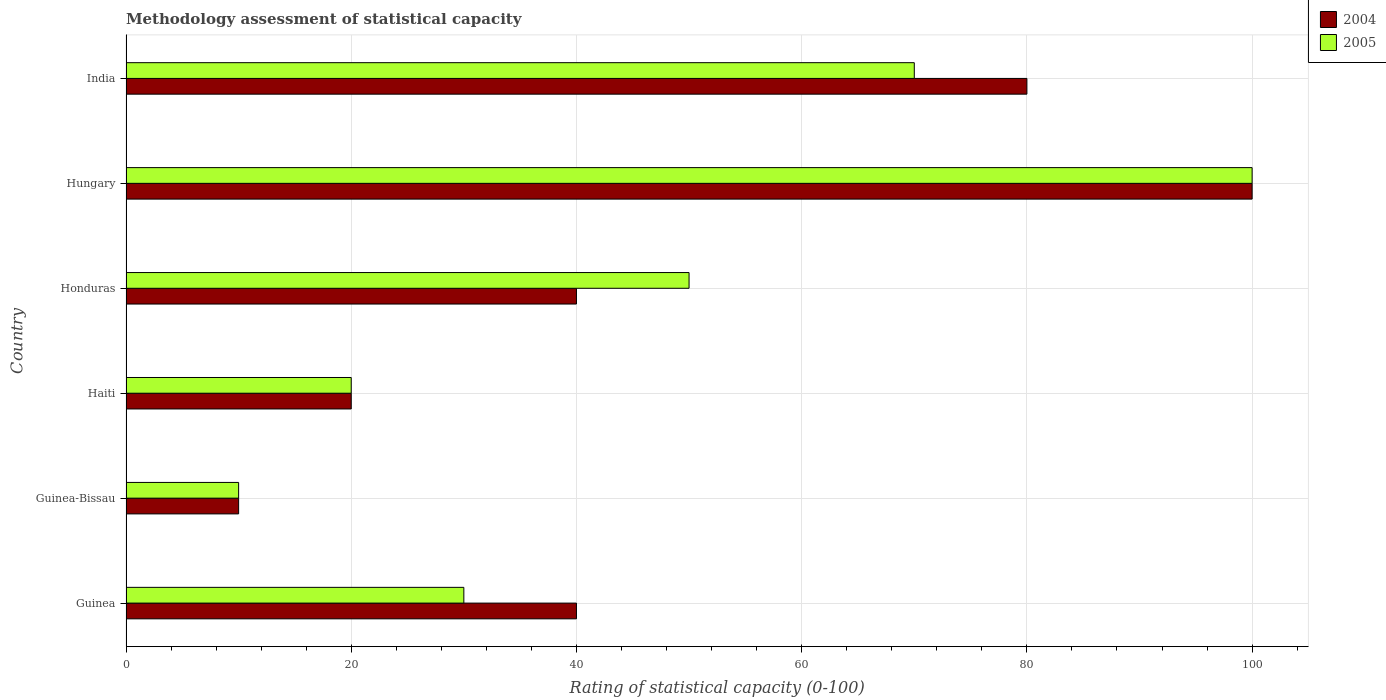How many different coloured bars are there?
Offer a very short reply. 2. How many groups of bars are there?
Provide a succinct answer. 6. What is the label of the 6th group of bars from the top?
Give a very brief answer. Guinea. Across all countries, what is the minimum rating of statistical capacity in 2005?
Ensure brevity in your answer.  10. In which country was the rating of statistical capacity in 2005 maximum?
Your response must be concise. Hungary. In which country was the rating of statistical capacity in 2004 minimum?
Offer a very short reply. Guinea-Bissau. What is the total rating of statistical capacity in 2005 in the graph?
Offer a very short reply. 280. What is the difference between the rating of statistical capacity in 2004 in Haiti and the rating of statistical capacity in 2005 in Hungary?
Provide a short and direct response. -80. What is the average rating of statistical capacity in 2004 per country?
Provide a short and direct response. 48.33. In how many countries, is the rating of statistical capacity in 2005 greater than 16 ?
Keep it short and to the point. 5. Is the difference between the rating of statistical capacity in 2005 in Honduras and India greater than the difference between the rating of statistical capacity in 2004 in Honduras and India?
Offer a very short reply. Yes. In how many countries, is the rating of statistical capacity in 2005 greater than the average rating of statistical capacity in 2005 taken over all countries?
Ensure brevity in your answer.  3. Is the sum of the rating of statistical capacity in 2005 in Guinea and India greater than the maximum rating of statistical capacity in 2004 across all countries?
Provide a short and direct response. No. Are all the bars in the graph horizontal?
Your answer should be compact. Yes. How many countries are there in the graph?
Give a very brief answer. 6. Does the graph contain grids?
Ensure brevity in your answer.  Yes. How are the legend labels stacked?
Your response must be concise. Vertical. What is the title of the graph?
Make the answer very short. Methodology assessment of statistical capacity. Does "2015" appear as one of the legend labels in the graph?
Make the answer very short. No. What is the label or title of the X-axis?
Ensure brevity in your answer.  Rating of statistical capacity (0-100). What is the Rating of statistical capacity (0-100) of 2005 in Guinea?
Provide a short and direct response. 30. What is the Rating of statistical capacity (0-100) of 2004 in Guinea-Bissau?
Offer a terse response. 10. What is the Rating of statistical capacity (0-100) in 2005 in Guinea-Bissau?
Offer a very short reply. 10. What is the Rating of statistical capacity (0-100) in 2004 in Haiti?
Offer a terse response. 20. What is the Rating of statistical capacity (0-100) of 2005 in Honduras?
Ensure brevity in your answer.  50. What is the Rating of statistical capacity (0-100) in 2004 in India?
Your response must be concise. 80. What is the total Rating of statistical capacity (0-100) in 2004 in the graph?
Provide a short and direct response. 290. What is the total Rating of statistical capacity (0-100) in 2005 in the graph?
Make the answer very short. 280. What is the difference between the Rating of statistical capacity (0-100) in 2004 in Guinea and that in Haiti?
Provide a succinct answer. 20. What is the difference between the Rating of statistical capacity (0-100) of 2005 in Guinea and that in Haiti?
Offer a terse response. 10. What is the difference between the Rating of statistical capacity (0-100) in 2004 in Guinea and that in Honduras?
Provide a short and direct response. 0. What is the difference between the Rating of statistical capacity (0-100) of 2005 in Guinea and that in Honduras?
Your answer should be compact. -20. What is the difference between the Rating of statistical capacity (0-100) in 2004 in Guinea and that in Hungary?
Keep it short and to the point. -60. What is the difference between the Rating of statistical capacity (0-100) of 2005 in Guinea and that in Hungary?
Give a very brief answer. -70. What is the difference between the Rating of statistical capacity (0-100) of 2004 in Guinea and that in India?
Offer a terse response. -40. What is the difference between the Rating of statistical capacity (0-100) in 2005 in Guinea and that in India?
Offer a terse response. -40. What is the difference between the Rating of statistical capacity (0-100) of 2005 in Guinea-Bissau and that in Haiti?
Your answer should be very brief. -10. What is the difference between the Rating of statistical capacity (0-100) of 2004 in Guinea-Bissau and that in Honduras?
Keep it short and to the point. -30. What is the difference between the Rating of statistical capacity (0-100) of 2004 in Guinea-Bissau and that in Hungary?
Your response must be concise. -90. What is the difference between the Rating of statistical capacity (0-100) of 2005 in Guinea-Bissau and that in Hungary?
Offer a very short reply. -90. What is the difference between the Rating of statistical capacity (0-100) in 2004 in Guinea-Bissau and that in India?
Offer a very short reply. -70. What is the difference between the Rating of statistical capacity (0-100) of 2005 in Guinea-Bissau and that in India?
Provide a short and direct response. -60. What is the difference between the Rating of statistical capacity (0-100) in 2004 in Haiti and that in Hungary?
Keep it short and to the point. -80. What is the difference between the Rating of statistical capacity (0-100) of 2005 in Haiti and that in Hungary?
Offer a terse response. -80. What is the difference between the Rating of statistical capacity (0-100) in 2004 in Haiti and that in India?
Your answer should be compact. -60. What is the difference between the Rating of statistical capacity (0-100) of 2005 in Haiti and that in India?
Offer a very short reply. -50. What is the difference between the Rating of statistical capacity (0-100) of 2004 in Honduras and that in Hungary?
Provide a short and direct response. -60. What is the difference between the Rating of statistical capacity (0-100) of 2005 in Honduras and that in Hungary?
Offer a very short reply. -50. What is the difference between the Rating of statistical capacity (0-100) of 2005 in Honduras and that in India?
Keep it short and to the point. -20. What is the difference between the Rating of statistical capacity (0-100) of 2005 in Hungary and that in India?
Provide a succinct answer. 30. What is the difference between the Rating of statistical capacity (0-100) in 2004 in Guinea and the Rating of statistical capacity (0-100) in 2005 in Honduras?
Your answer should be very brief. -10. What is the difference between the Rating of statistical capacity (0-100) of 2004 in Guinea and the Rating of statistical capacity (0-100) of 2005 in Hungary?
Provide a succinct answer. -60. What is the difference between the Rating of statistical capacity (0-100) of 2004 in Guinea-Bissau and the Rating of statistical capacity (0-100) of 2005 in Haiti?
Your answer should be very brief. -10. What is the difference between the Rating of statistical capacity (0-100) in 2004 in Guinea-Bissau and the Rating of statistical capacity (0-100) in 2005 in Honduras?
Make the answer very short. -40. What is the difference between the Rating of statistical capacity (0-100) of 2004 in Guinea-Bissau and the Rating of statistical capacity (0-100) of 2005 in Hungary?
Give a very brief answer. -90. What is the difference between the Rating of statistical capacity (0-100) of 2004 in Guinea-Bissau and the Rating of statistical capacity (0-100) of 2005 in India?
Provide a succinct answer. -60. What is the difference between the Rating of statistical capacity (0-100) of 2004 in Haiti and the Rating of statistical capacity (0-100) of 2005 in Honduras?
Provide a succinct answer. -30. What is the difference between the Rating of statistical capacity (0-100) in 2004 in Haiti and the Rating of statistical capacity (0-100) in 2005 in Hungary?
Provide a succinct answer. -80. What is the difference between the Rating of statistical capacity (0-100) in 2004 in Haiti and the Rating of statistical capacity (0-100) in 2005 in India?
Provide a short and direct response. -50. What is the difference between the Rating of statistical capacity (0-100) of 2004 in Honduras and the Rating of statistical capacity (0-100) of 2005 in Hungary?
Keep it short and to the point. -60. What is the difference between the Rating of statistical capacity (0-100) in 2004 in Honduras and the Rating of statistical capacity (0-100) in 2005 in India?
Your response must be concise. -30. What is the average Rating of statistical capacity (0-100) of 2004 per country?
Ensure brevity in your answer.  48.33. What is the average Rating of statistical capacity (0-100) of 2005 per country?
Give a very brief answer. 46.67. What is the difference between the Rating of statistical capacity (0-100) of 2004 and Rating of statistical capacity (0-100) of 2005 in Haiti?
Ensure brevity in your answer.  0. What is the difference between the Rating of statistical capacity (0-100) of 2004 and Rating of statistical capacity (0-100) of 2005 in Honduras?
Ensure brevity in your answer.  -10. What is the difference between the Rating of statistical capacity (0-100) of 2004 and Rating of statistical capacity (0-100) of 2005 in India?
Your answer should be very brief. 10. What is the ratio of the Rating of statistical capacity (0-100) of 2004 in Guinea to that in Guinea-Bissau?
Your answer should be compact. 4. What is the ratio of the Rating of statistical capacity (0-100) in 2004 in Guinea to that in Haiti?
Keep it short and to the point. 2. What is the ratio of the Rating of statistical capacity (0-100) of 2005 in Guinea to that in Haiti?
Make the answer very short. 1.5. What is the ratio of the Rating of statistical capacity (0-100) of 2004 in Guinea to that in Honduras?
Ensure brevity in your answer.  1. What is the ratio of the Rating of statistical capacity (0-100) in 2005 in Guinea to that in Honduras?
Ensure brevity in your answer.  0.6. What is the ratio of the Rating of statistical capacity (0-100) in 2004 in Guinea to that in Hungary?
Offer a terse response. 0.4. What is the ratio of the Rating of statistical capacity (0-100) of 2005 in Guinea to that in India?
Provide a succinct answer. 0.43. What is the ratio of the Rating of statistical capacity (0-100) of 2004 in Guinea-Bissau to that in Haiti?
Your answer should be compact. 0.5. What is the ratio of the Rating of statistical capacity (0-100) in 2005 in Guinea-Bissau to that in Haiti?
Your response must be concise. 0.5. What is the ratio of the Rating of statistical capacity (0-100) of 2005 in Guinea-Bissau to that in Honduras?
Keep it short and to the point. 0.2. What is the ratio of the Rating of statistical capacity (0-100) in 2004 in Guinea-Bissau to that in Hungary?
Provide a short and direct response. 0.1. What is the ratio of the Rating of statistical capacity (0-100) of 2005 in Guinea-Bissau to that in Hungary?
Offer a terse response. 0.1. What is the ratio of the Rating of statistical capacity (0-100) in 2004 in Guinea-Bissau to that in India?
Offer a terse response. 0.12. What is the ratio of the Rating of statistical capacity (0-100) of 2005 in Guinea-Bissau to that in India?
Your response must be concise. 0.14. What is the ratio of the Rating of statistical capacity (0-100) of 2004 in Haiti to that in Honduras?
Your answer should be compact. 0.5. What is the ratio of the Rating of statistical capacity (0-100) in 2004 in Haiti to that in Hungary?
Offer a terse response. 0.2. What is the ratio of the Rating of statistical capacity (0-100) of 2005 in Haiti to that in Hungary?
Offer a very short reply. 0.2. What is the ratio of the Rating of statistical capacity (0-100) of 2005 in Haiti to that in India?
Offer a very short reply. 0.29. What is the ratio of the Rating of statistical capacity (0-100) of 2004 in Honduras to that in Hungary?
Offer a terse response. 0.4. What is the ratio of the Rating of statistical capacity (0-100) in 2005 in Hungary to that in India?
Provide a short and direct response. 1.43. What is the difference between the highest and the second highest Rating of statistical capacity (0-100) of 2004?
Provide a succinct answer. 20. What is the difference between the highest and the lowest Rating of statistical capacity (0-100) of 2004?
Your answer should be very brief. 90. What is the difference between the highest and the lowest Rating of statistical capacity (0-100) in 2005?
Your response must be concise. 90. 